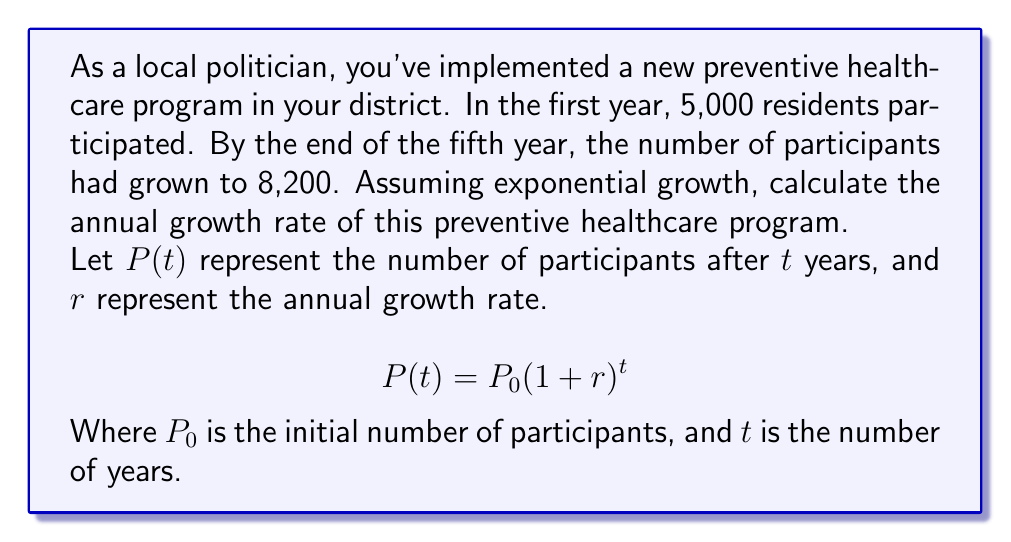What is the answer to this math problem? To solve this problem, we'll use the exponential growth formula:

$$P(t) = P_0(1 + r)^t$$

We know:
$P_0 = 5,000$ (initial participants)
$P(5) = 8,200$ (participants after 5 years)
$t = 5$ (years)

Let's substitute these values into the formula:

$$8,200 = 5,000(1 + r)^5$$

Now, we'll solve for $r$:

1) Divide both sides by 5,000:
   $$\frac{8,200}{5,000} = (1 + r)^5$$

2) Simplify:
   $$1.64 = (1 + r)^5$$

3) Take the fifth root of both sides:
   $$\sqrt[5]{1.64} = 1 + r$$

4) Simplify (using a calculator):
   $$1.1040 = 1 + r$$

5) Subtract 1 from both sides:
   $$0.1040 = r$$

6) Convert to a percentage:
   $$r = 0.1040 \times 100\% = 10.40\%$$

Therefore, the annual growth rate is approximately 10.40%.
Answer: The annual growth rate of the preventive healthcare program is approximately 10.40%. 